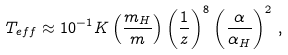Convert formula to latex. <formula><loc_0><loc_0><loc_500><loc_500>T _ { e f f } \approx 1 0 ^ { - 1 } K \left ( \frac { m _ { H } } { m } \right ) \left ( \frac { 1 \AA } { z } \right ) ^ { 8 } \left ( \frac { \alpha } { \alpha _ { H } } \right ) ^ { 2 } \, ,</formula> 